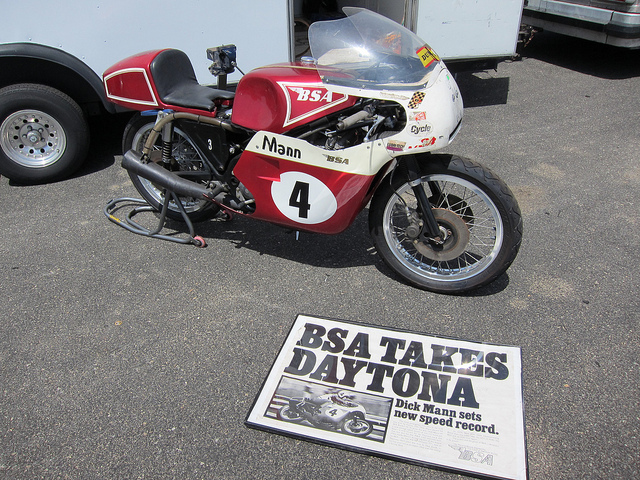<image>What is the license plate number of the motorcycle? It is unknown what the license plate number of the motorcycle is. What is the license plate number of the motorcycle? The license plate number of the motorcycle is 4. 